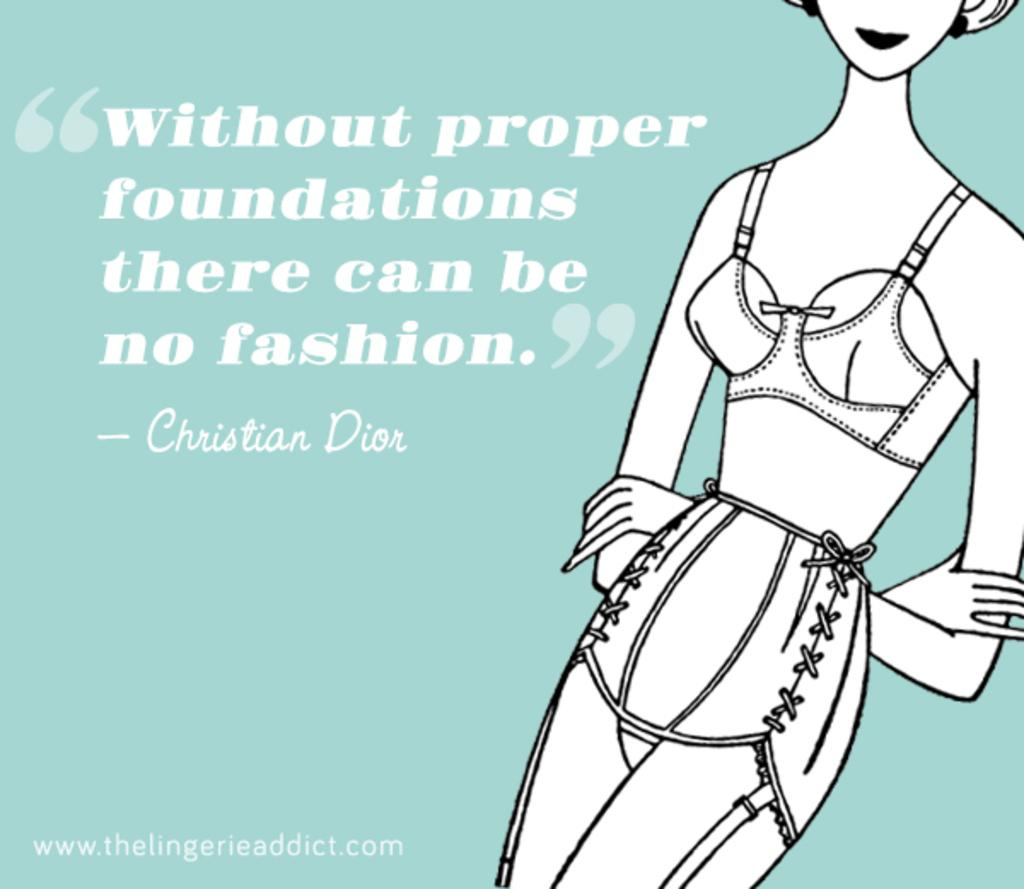What is the main subject of the poster in the image? The main subject of the poster in the image is an animated image of a woman. What is the woman doing in the poster? The woman is standing near a quotation in the poster. What can be seen on the poster besides the animated image of the woman? There is a watermark on the poster. What is the color of the background in the poster? The background of the poster is blue in color. How many apples are hanging from the coil in the image? There are no apples or coils present in the image; the image features a poster with an animated image of a woman. 